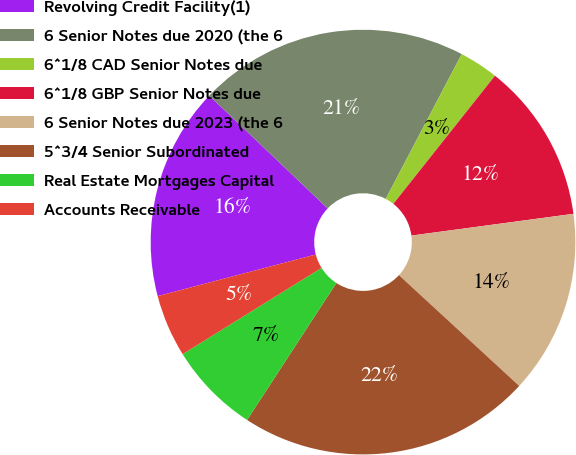Convert chart. <chart><loc_0><loc_0><loc_500><loc_500><pie_chart><fcel>Revolving Credit Facility(1)<fcel>6 Senior Notes due 2020 (the 6<fcel>6^1/8 CAD Senior Notes due<fcel>6^1/8 GBP Senior Notes due<fcel>6 Senior Notes due 2023 (the 6<fcel>5^3/4 Senior Subordinated<fcel>Real Estate Mortgages Capital<fcel>Accounts Receivable<nl><fcel>16.21%<fcel>20.58%<fcel>2.98%<fcel>12.2%<fcel>13.97%<fcel>22.35%<fcel>6.96%<fcel>4.75%<nl></chart> 